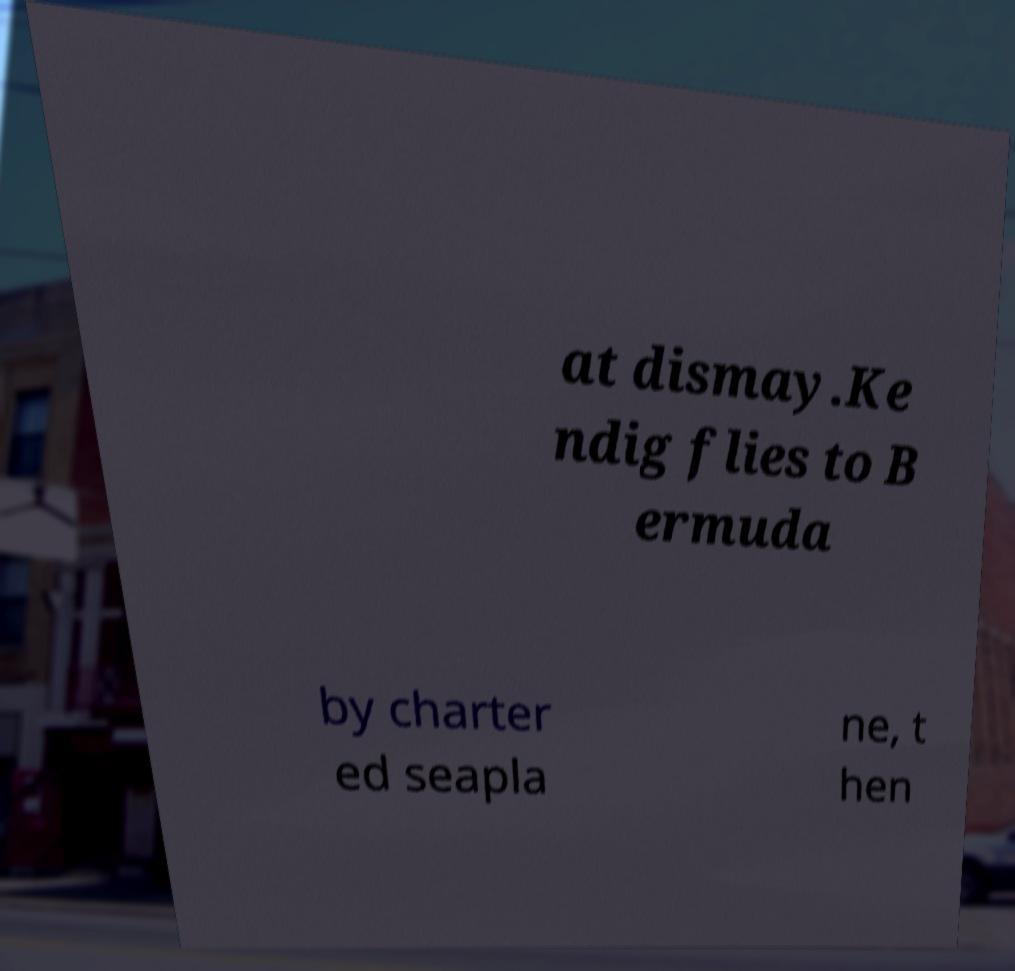There's text embedded in this image that I need extracted. Can you transcribe it verbatim? at dismay.Ke ndig flies to B ermuda by charter ed seapla ne, t hen 